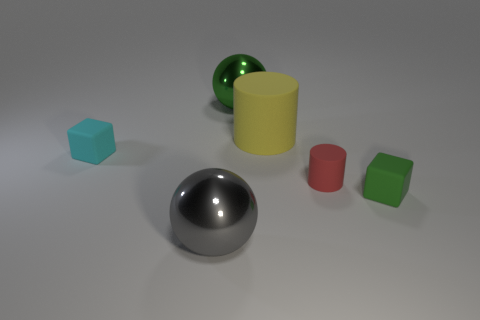Add 2 tiny blocks. How many objects exist? 8 Subtract 2 blocks. How many blocks are left? 0 Subtract all cyan blocks. How many blocks are left? 1 Subtract all red cylinders. How many gray balls are left? 1 Subtract all large green spheres. Subtract all large blue shiny cylinders. How many objects are left? 5 Add 6 tiny red rubber things. How many tiny red rubber things are left? 7 Add 4 green shiny things. How many green shiny things exist? 5 Subtract 0 cyan cylinders. How many objects are left? 6 Subtract all spheres. How many objects are left? 4 Subtract all green balls. Subtract all red blocks. How many balls are left? 1 